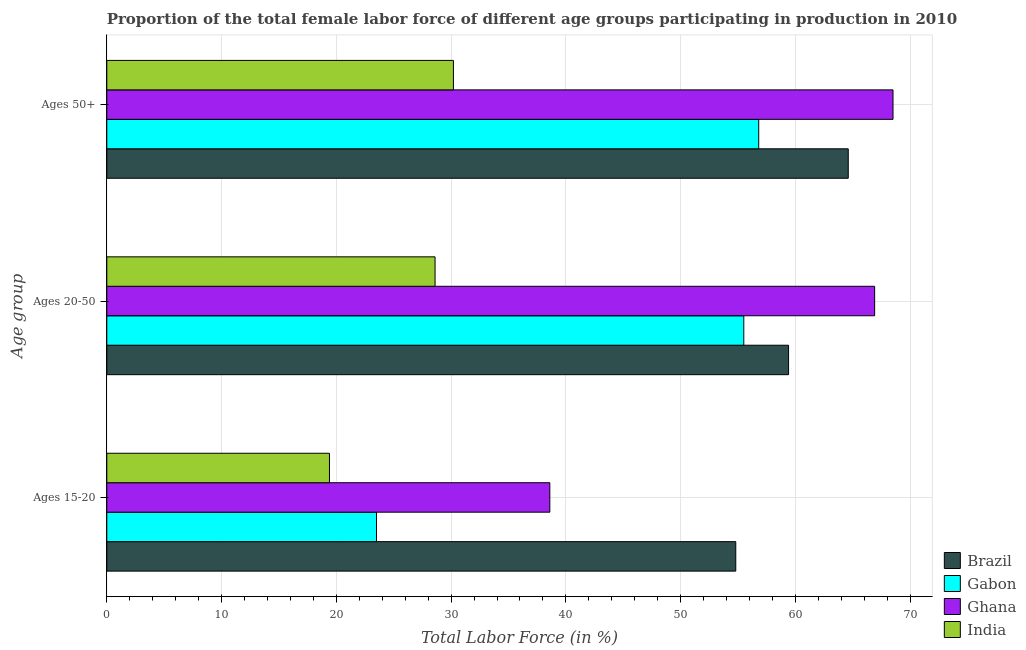Are the number of bars per tick equal to the number of legend labels?
Provide a short and direct response. Yes. What is the label of the 3rd group of bars from the top?
Make the answer very short. Ages 15-20. What is the percentage of female labor force within the age group 20-50 in Gabon?
Ensure brevity in your answer.  55.5. Across all countries, what is the maximum percentage of female labor force above age 50?
Offer a very short reply. 68.5. Across all countries, what is the minimum percentage of female labor force within the age group 20-50?
Keep it short and to the point. 28.6. What is the total percentage of female labor force above age 50 in the graph?
Your response must be concise. 220.1. What is the difference between the percentage of female labor force above age 50 in Gabon and that in Ghana?
Your answer should be compact. -11.7. What is the difference between the percentage of female labor force within the age group 20-50 in India and the percentage of female labor force above age 50 in Brazil?
Ensure brevity in your answer.  -36. What is the average percentage of female labor force within the age group 20-50 per country?
Your response must be concise. 52.6. What is the difference between the percentage of female labor force above age 50 and percentage of female labor force within the age group 20-50 in Gabon?
Keep it short and to the point. 1.3. What is the ratio of the percentage of female labor force within the age group 15-20 in Brazil to that in Gabon?
Offer a very short reply. 2.33. What is the difference between the highest and the second highest percentage of female labor force within the age group 15-20?
Your answer should be compact. 16.2. What is the difference between the highest and the lowest percentage of female labor force above age 50?
Your answer should be compact. 38.3. In how many countries, is the percentage of female labor force above age 50 greater than the average percentage of female labor force above age 50 taken over all countries?
Keep it short and to the point. 3. What does the 3rd bar from the bottom in Ages 15-20 represents?
Make the answer very short. Ghana. Are all the bars in the graph horizontal?
Your response must be concise. Yes. Are the values on the major ticks of X-axis written in scientific E-notation?
Make the answer very short. No. Where does the legend appear in the graph?
Your response must be concise. Bottom right. How are the legend labels stacked?
Your response must be concise. Vertical. What is the title of the graph?
Provide a succinct answer. Proportion of the total female labor force of different age groups participating in production in 2010. What is the label or title of the X-axis?
Provide a short and direct response. Total Labor Force (in %). What is the label or title of the Y-axis?
Provide a short and direct response. Age group. What is the Total Labor Force (in %) of Brazil in Ages 15-20?
Your answer should be very brief. 54.8. What is the Total Labor Force (in %) of Gabon in Ages 15-20?
Give a very brief answer. 23.5. What is the Total Labor Force (in %) in Ghana in Ages 15-20?
Provide a succinct answer. 38.6. What is the Total Labor Force (in %) in India in Ages 15-20?
Give a very brief answer. 19.4. What is the Total Labor Force (in %) of Brazil in Ages 20-50?
Provide a short and direct response. 59.4. What is the Total Labor Force (in %) in Gabon in Ages 20-50?
Your response must be concise. 55.5. What is the Total Labor Force (in %) of Ghana in Ages 20-50?
Offer a very short reply. 66.9. What is the Total Labor Force (in %) in India in Ages 20-50?
Ensure brevity in your answer.  28.6. What is the Total Labor Force (in %) in Brazil in Ages 50+?
Keep it short and to the point. 64.6. What is the Total Labor Force (in %) of Gabon in Ages 50+?
Offer a terse response. 56.8. What is the Total Labor Force (in %) in Ghana in Ages 50+?
Offer a very short reply. 68.5. What is the Total Labor Force (in %) of India in Ages 50+?
Offer a terse response. 30.2. Across all Age group, what is the maximum Total Labor Force (in %) in Brazil?
Provide a succinct answer. 64.6. Across all Age group, what is the maximum Total Labor Force (in %) of Gabon?
Offer a very short reply. 56.8. Across all Age group, what is the maximum Total Labor Force (in %) in Ghana?
Ensure brevity in your answer.  68.5. Across all Age group, what is the maximum Total Labor Force (in %) in India?
Provide a short and direct response. 30.2. Across all Age group, what is the minimum Total Labor Force (in %) in Brazil?
Provide a short and direct response. 54.8. Across all Age group, what is the minimum Total Labor Force (in %) of Ghana?
Offer a terse response. 38.6. Across all Age group, what is the minimum Total Labor Force (in %) in India?
Give a very brief answer. 19.4. What is the total Total Labor Force (in %) of Brazil in the graph?
Give a very brief answer. 178.8. What is the total Total Labor Force (in %) of Gabon in the graph?
Ensure brevity in your answer.  135.8. What is the total Total Labor Force (in %) in Ghana in the graph?
Provide a succinct answer. 174. What is the total Total Labor Force (in %) in India in the graph?
Ensure brevity in your answer.  78.2. What is the difference between the Total Labor Force (in %) in Gabon in Ages 15-20 and that in Ages 20-50?
Provide a short and direct response. -32. What is the difference between the Total Labor Force (in %) of Ghana in Ages 15-20 and that in Ages 20-50?
Ensure brevity in your answer.  -28.3. What is the difference between the Total Labor Force (in %) of India in Ages 15-20 and that in Ages 20-50?
Make the answer very short. -9.2. What is the difference between the Total Labor Force (in %) in Gabon in Ages 15-20 and that in Ages 50+?
Offer a terse response. -33.3. What is the difference between the Total Labor Force (in %) in Ghana in Ages 15-20 and that in Ages 50+?
Keep it short and to the point. -29.9. What is the difference between the Total Labor Force (in %) of Brazil in Ages 20-50 and that in Ages 50+?
Your answer should be compact. -5.2. What is the difference between the Total Labor Force (in %) of Ghana in Ages 20-50 and that in Ages 50+?
Offer a very short reply. -1.6. What is the difference between the Total Labor Force (in %) in Brazil in Ages 15-20 and the Total Labor Force (in %) in India in Ages 20-50?
Keep it short and to the point. 26.2. What is the difference between the Total Labor Force (in %) in Gabon in Ages 15-20 and the Total Labor Force (in %) in Ghana in Ages 20-50?
Provide a succinct answer. -43.4. What is the difference between the Total Labor Force (in %) of Ghana in Ages 15-20 and the Total Labor Force (in %) of India in Ages 20-50?
Offer a very short reply. 10. What is the difference between the Total Labor Force (in %) in Brazil in Ages 15-20 and the Total Labor Force (in %) in Gabon in Ages 50+?
Your response must be concise. -2. What is the difference between the Total Labor Force (in %) in Brazil in Ages 15-20 and the Total Labor Force (in %) in Ghana in Ages 50+?
Offer a terse response. -13.7. What is the difference between the Total Labor Force (in %) in Brazil in Ages 15-20 and the Total Labor Force (in %) in India in Ages 50+?
Your response must be concise. 24.6. What is the difference between the Total Labor Force (in %) in Gabon in Ages 15-20 and the Total Labor Force (in %) in Ghana in Ages 50+?
Provide a succinct answer. -45. What is the difference between the Total Labor Force (in %) in Ghana in Ages 15-20 and the Total Labor Force (in %) in India in Ages 50+?
Your response must be concise. 8.4. What is the difference between the Total Labor Force (in %) of Brazil in Ages 20-50 and the Total Labor Force (in %) of Gabon in Ages 50+?
Give a very brief answer. 2.6. What is the difference between the Total Labor Force (in %) in Brazil in Ages 20-50 and the Total Labor Force (in %) in Ghana in Ages 50+?
Your answer should be compact. -9.1. What is the difference between the Total Labor Force (in %) in Brazil in Ages 20-50 and the Total Labor Force (in %) in India in Ages 50+?
Make the answer very short. 29.2. What is the difference between the Total Labor Force (in %) in Gabon in Ages 20-50 and the Total Labor Force (in %) in Ghana in Ages 50+?
Offer a very short reply. -13. What is the difference between the Total Labor Force (in %) of Gabon in Ages 20-50 and the Total Labor Force (in %) of India in Ages 50+?
Your response must be concise. 25.3. What is the difference between the Total Labor Force (in %) of Ghana in Ages 20-50 and the Total Labor Force (in %) of India in Ages 50+?
Your answer should be compact. 36.7. What is the average Total Labor Force (in %) of Brazil per Age group?
Provide a succinct answer. 59.6. What is the average Total Labor Force (in %) of Gabon per Age group?
Your answer should be very brief. 45.27. What is the average Total Labor Force (in %) in Ghana per Age group?
Keep it short and to the point. 58. What is the average Total Labor Force (in %) in India per Age group?
Keep it short and to the point. 26.07. What is the difference between the Total Labor Force (in %) of Brazil and Total Labor Force (in %) of Gabon in Ages 15-20?
Ensure brevity in your answer.  31.3. What is the difference between the Total Labor Force (in %) in Brazil and Total Labor Force (in %) in Ghana in Ages 15-20?
Your answer should be compact. 16.2. What is the difference between the Total Labor Force (in %) of Brazil and Total Labor Force (in %) of India in Ages 15-20?
Ensure brevity in your answer.  35.4. What is the difference between the Total Labor Force (in %) of Gabon and Total Labor Force (in %) of Ghana in Ages 15-20?
Your response must be concise. -15.1. What is the difference between the Total Labor Force (in %) in Gabon and Total Labor Force (in %) in India in Ages 15-20?
Give a very brief answer. 4.1. What is the difference between the Total Labor Force (in %) of Brazil and Total Labor Force (in %) of Gabon in Ages 20-50?
Offer a terse response. 3.9. What is the difference between the Total Labor Force (in %) of Brazil and Total Labor Force (in %) of India in Ages 20-50?
Your answer should be very brief. 30.8. What is the difference between the Total Labor Force (in %) of Gabon and Total Labor Force (in %) of India in Ages 20-50?
Give a very brief answer. 26.9. What is the difference between the Total Labor Force (in %) in Ghana and Total Labor Force (in %) in India in Ages 20-50?
Your response must be concise. 38.3. What is the difference between the Total Labor Force (in %) in Brazil and Total Labor Force (in %) in Gabon in Ages 50+?
Offer a terse response. 7.8. What is the difference between the Total Labor Force (in %) in Brazil and Total Labor Force (in %) in India in Ages 50+?
Provide a succinct answer. 34.4. What is the difference between the Total Labor Force (in %) of Gabon and Total Labor Force (in %) of Ghana in Ages 50+?
Keep it short and to the point. -11.7. What is the difference between the Total Labor Force (in %) of Gabon and Total Labor Force (in %) of India in Ages 50+?
Offer a terse response. 26.6. What is the difference between the Total Labor Force (in %) in Ghana and Total Labor Force (in %) in India in Ages 50+?
Provide a short and direct response. 38.3. What is the ratio of the Total Labor Force (in %) of Brazil in Ages 15-20 to that in Ages 20-50?
Your answer should be very brief. 0.92. What is the ratio of the Total Labor Force (in %) in Gabon in Ages 15-20 to that in Ages 20-50?
Provide a short and direct response. 0.42. What is the ratio of the Total Labor Force (in %) in Ghana in Ages 15-20 to that in Ages 20-50?
Your answer should be compact. 0.58. What is the ratio of the Total Labor Force (in %) in India in Ages 15-20 to that in Ages 20-50?
Provide a short and direct response. 0.68. What is the ratio of the Total Labor Force (in %) of Brazil in Ages 15-20 to that in Ages 50+?
Make the answer very short. 0.85. What is the ratio of the Total Labor Force (in %) of Gabon in Ages 15-20 to that in Ages 50+?
Ensure brevity in your answer.  0.41. What is the ratio of the Total Labor Force (in %) in Ghana in Ages 15-20 to that in Ages 50+?
Your answer should be very brief. 0.56. What is the ratio of the Total Labor Force (in %) of India in Ages 15-20 to that in Ages 50+?
Make the answer very short. 0.64. What is the ratio of the Total Labor Force (in %) of Brazil in Ages 20-50 to that in Ages 50+?
Keep it short and to the point. 0.92. What is the ratio of the Total Labor Force (in %) in Gabon in Ages 20-50 to that in Ages 50+?
Ensure brevity in your answer.  0.98. What is the ratio of the Total Labor Force (in %) of Ghana in Ages 20-50 to that in Ages 50+?
Offer a terse response. 0.98. What is the ratio of the Total Labor Force (in %) in India in Ages 20-50 to that in Ages 50+?
Offer a very short reply. 0.95. What is the difference between the highest and the second highest Total Labor Force (in %) of Brazil?
Make the answer very short. 5.2. What is the difference between the highest and the second highest Total Labor Force (in %) in Gabon?
Your response must be concise. 1.3. What is the difference between the highest and the second highest Total Labor Force (in %) in India?
Make the answer very short. 1.6. What is the difference between the highest and the lowest Total Labor Force (in %) in Gabon?
Provide a succinct answer. 33.3. What is the difference between the highest and the lowest Total Labor Force (in %) of Ghana?
Provide a succinct answer. 29.9. What is the difference between the highest and the lowest Total Labor Force (in %) of India?
Offer a very short reply. 10.8. 